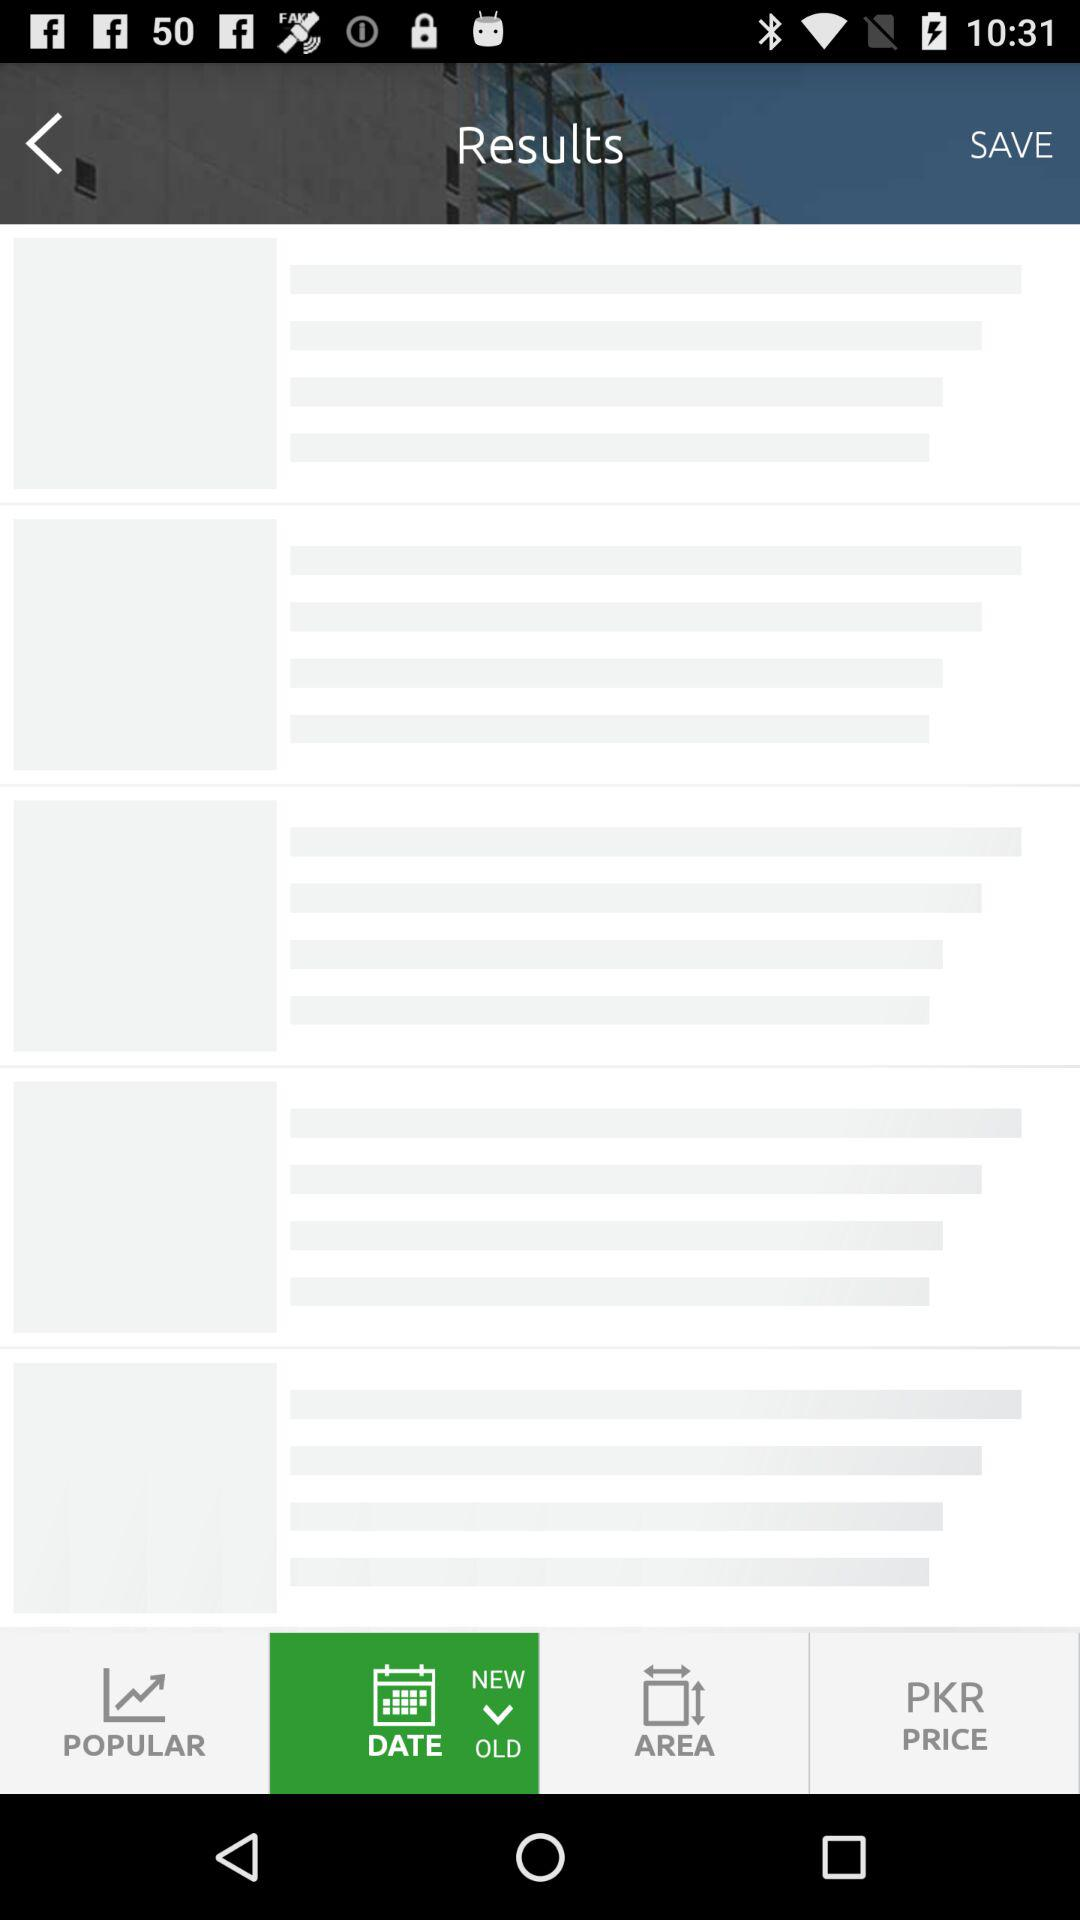What is the price of the bungalow? The price of the bungalow is 4 crore. 